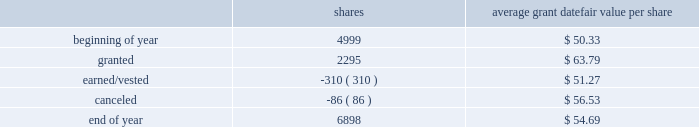2018 emerson annual report | 51 as of september 30 , 2018 , 1874750 shares awarded primarily in 2016 were outstanding , contingent on the company achieving its performance objectives through 2018 .
The objectives for these shares were met at the 97 percent level at the end of 2018 and 1818508 shares will be distributed in early 2019 .
Additionally , the rights to receive a maximum of 2261700 and 2375313 common shares were awarded in 2018 and 2017 , respectively , under the new performance shares program , and are outstanding and contingent upon the company achieving its performance objectives through 2020 and 2019 , respectively .
Incentive shares plans also include restricted stock awards which involve distribution of common stock to key management employees subject to cliff vesting at the end of service periods ranging from three to ten years .
The fair value of restricted stock awards is determined based on the average of the high and low market prices of the company 2019s common stock on the date of grant , with compensation expense recognized ratably over the applicable service period .
In 2018 , 310000 shares of restricted stock vested as a result of participants fulfilling the applicable service requirements .
Consequently , 167837 shares were issued while 142163 shares were withheld for income taxes in accordance with minimum withholding requirements .
As of september 30 , 2018 , there were 1276200 shares of unvested restricted stock outstanding .
The total fair value of shares distributed under incentive shares plans was $ 20 , $ 245 and $ 11 , respectively , in 2018 , 2017 and 2016 , of which $ 9 , $ 101 and $ 4 was paid in cash , primarily for tax withholding .
As of september 30 , 2018 , 10.3 million shares remained available for award under incentive shares plans .
Changes in shares outstanding but not yet earned under incentive shares plans during the year ended september 30 , 2018 follow ( shares in thousands ; assumes 100 percent payout of unvested awards ) : average grant date shares fair value per share .
Total compensation expense for stock options and incentive shares was $ 216 , $ 115 and $ 159 for 2018 , 2017 and 2016 , respectively , of which $ 5 and $ 14 was included in discontinued operations for 2017 and 2016 , respectively .
The increase in expense for 2018 reflects an increase in the company 2019s stock price and progress toward achieving its performance objectives .
The decrease in expense for 2017 reflects the impact of changes in the stock price .
Income tax benefits recognized in the income statement for these compensation arrangements during 2018 , 2017 and 2016 were $ 42 , $ 33 and $ 45 , respectively .
As of september 30 , 2018 , total unrecognized compensation expense related to unvested shares awarded under these plans was $ 182 , which is expected to be recognized over a weighted-average period of 1.1 years .
In addition to the employee stock option and incentive shares plans , in 2018 the company awarded 12228 shares of restricted stock and 2038 restricted stock units under the restricted stock plan for non-management directors .
As of september 30 , 2018 , 159965 shares were available for issuance under this plan .
( 16 ) common and preferred stock at september 30 , 2018 , 37.0 million shares of common stock were reserved for issuance under the company 2019s stock-based compensation plans .
During 2018 , 15.1 million common shares were purchased and 2.6 million treasury shares were reissued .
In 2017 , 6.6 million common shares were purchased and 5.5 million treasury shares were reissued .
At september 30 , 2018 and 2017 , the company had 5.4 million shares of $ 2.50 par value preferred stock authorized , with none issued. .
During 2018 what was the net purchase of common shares in millions? 
Rationale: the net number is useful for year over year comparisons .
Computations: (15.1 - 2.6)
Answer: 12.5. 